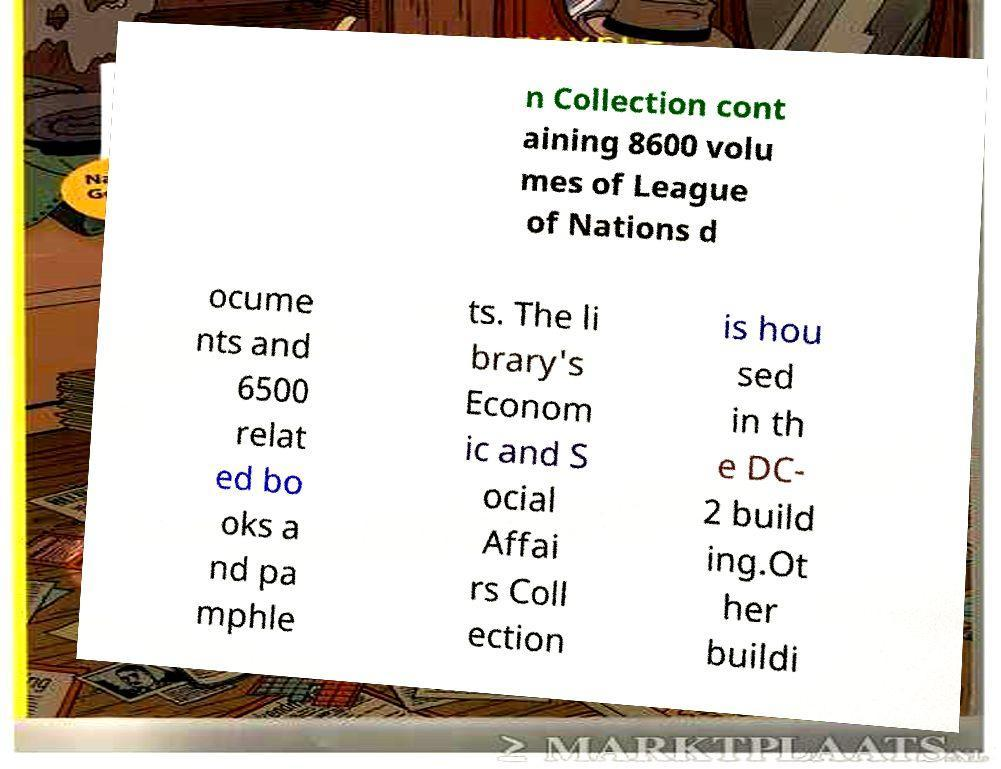There's text embedded in this image that I need extracted. Can you transcribe it verbatim? n Collection cont aining 8600 volu mes of League of Nations d ocume nts and 6500 relat ed bo oks a nd pa mphle ts. The li brary's Econom ic and S ocial Affai rs Coll ection is hou sed in th e DC- 2 build ing.Ot her buildi 